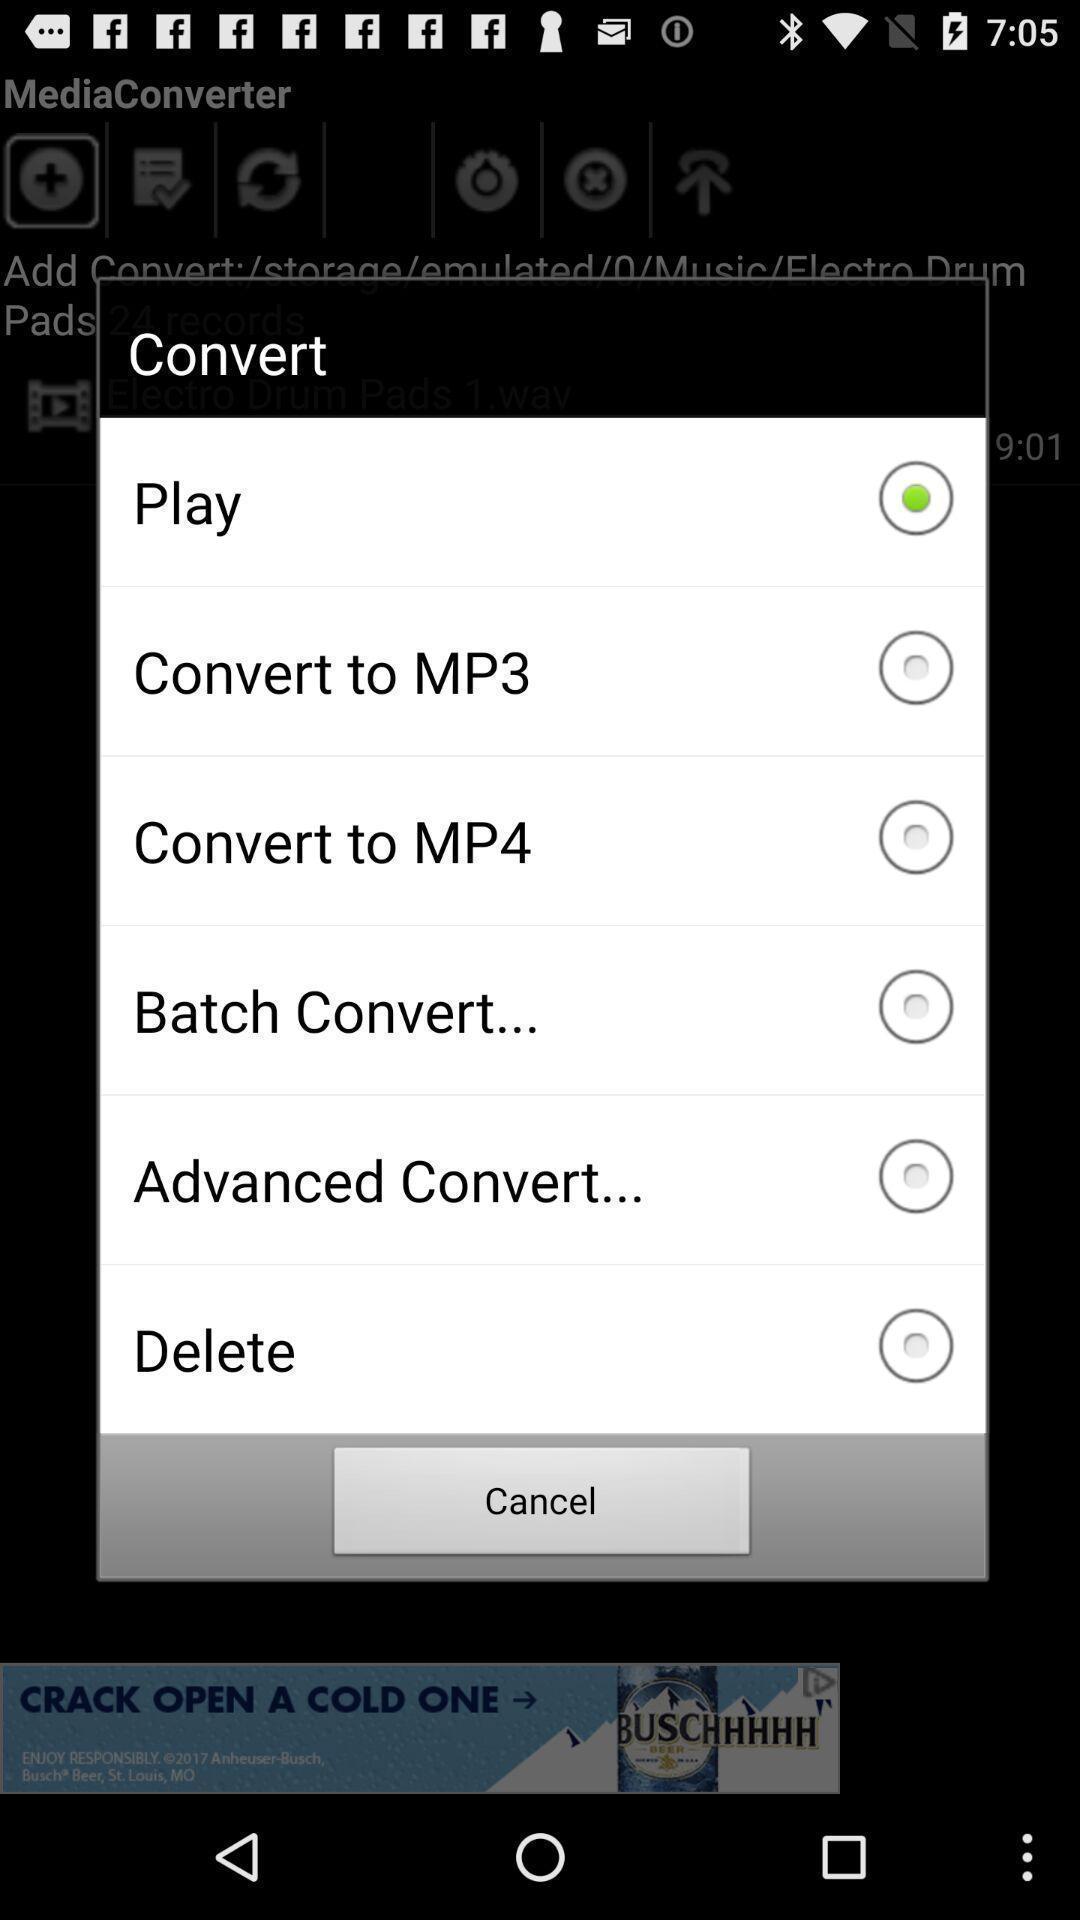Provide a description of this screenshot. Pop-up shows convert with multiple options list. 